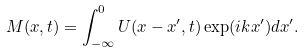<formula> <loc_0><loc_0><loc_500><loc_500>M ( x , t ) = \int ^ { 0 } _ { - \infty } U ( x - x ^ { \prime } , t ) \exp ( i k x ^ { \prime } ) d x ^ { \prime } .</formula> 